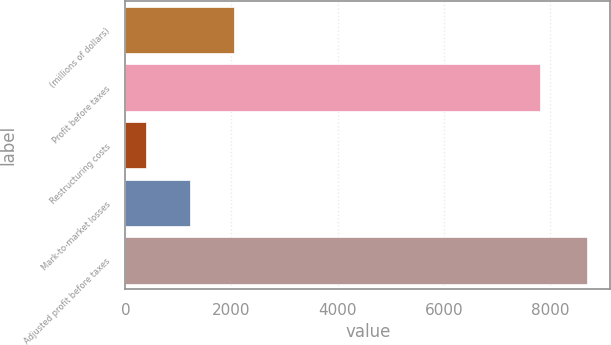Convert chart to OTSL. <chart><loc_0><loc_0><loc_500><loc_500><bar_chart><fcel>(millions of dollars)<fcel>Profit before taxes<fcel>Restructuring costs<fcel>Mark-to-market losses<fcel>Adjusted profit before taxes<nl><fcel>2049.4<fcel>7822<fcel>386<fcel>1217.7<fcel>8703<nl></chart> 